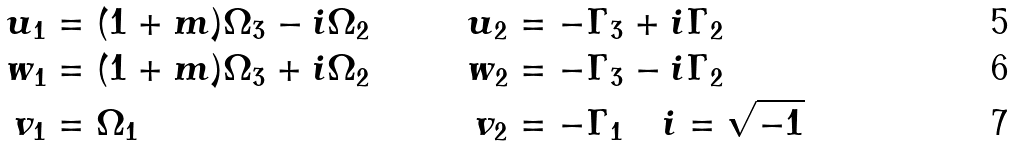<formula> <loc_0><loc_0><loc_500><loc_500>u _ { 1 } & = ( 1 + m ) \Omega _ { 3 } - i \Omega _ { 2 } & u _ { 2 } & = - \Gamma _ { 3 } + i \Gamma _ { 2 } & \\ \quad w _ { 1 } & = ( 1 + m ) \Omega _ { 3 } + i \Omega _ { 2 } & w _ { 2 } & = - \Gamma _ { 3 } - i \Gamma _ { 2 } & \\ \quad v _ { 1 } & = \Omega _ { 1 } & v _ { 2 } & = - \Gamma _ { 1 } \quad i = \sqrt { - 1 } \ &</formula> 